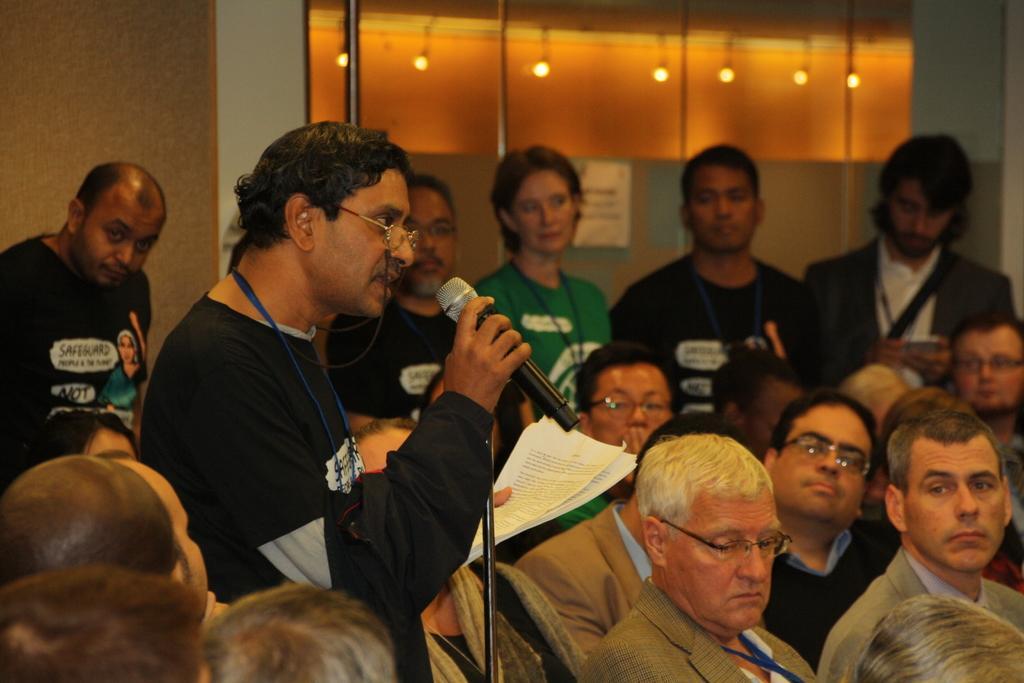Could you give a brief overview of what you see in this image? Here we can see a person holding a microphone in his hand and he is speaking. Here we can see a few people and they are paying attention to the speaker. 